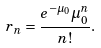<formula> <loc_0><loc_0><loc_500><loc_500>r _ { n } = \frac { e ^ { - \mu _ { 0 } } \mu _ { 0 } ^ { n } } { n ! } .</formula> 